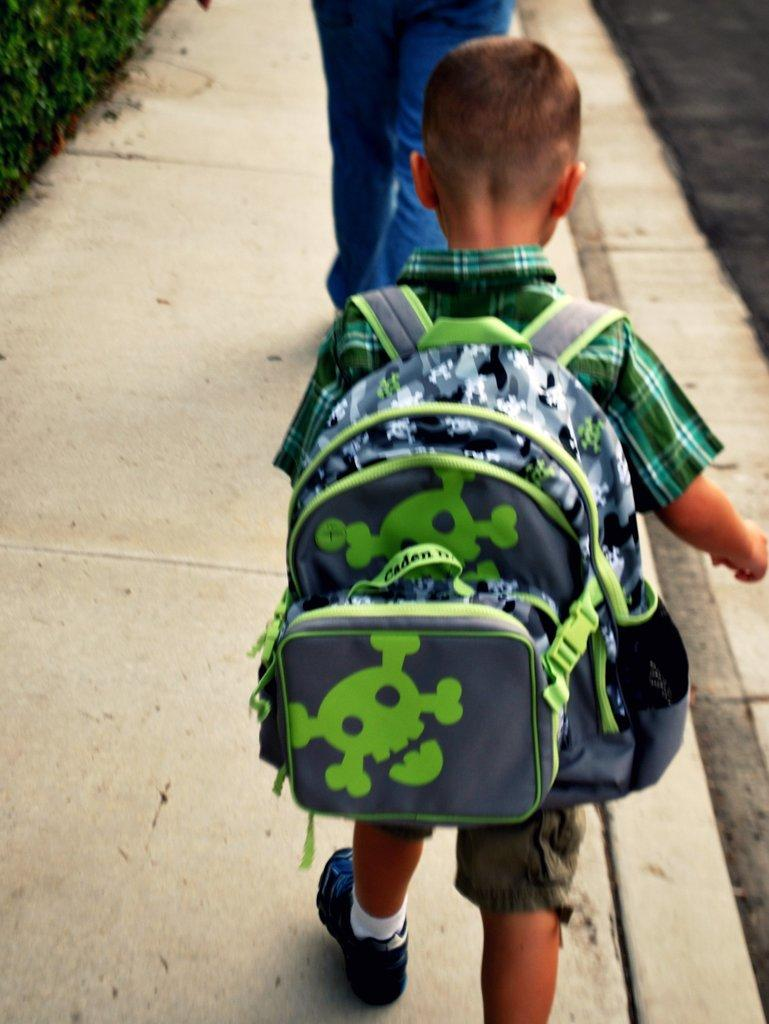Who is the main subject in the image? There is a boy in the image. What is the boy doing in the image? The boy is walking in the image. What is the boy wearing in the image? The boy is wearing a green color bag in the image. How many ducks are following the boy in the image? There are no ducks present in the image. What type of paint is being used by the boy in the image? There is no paint or painting activity depicted in the image. 